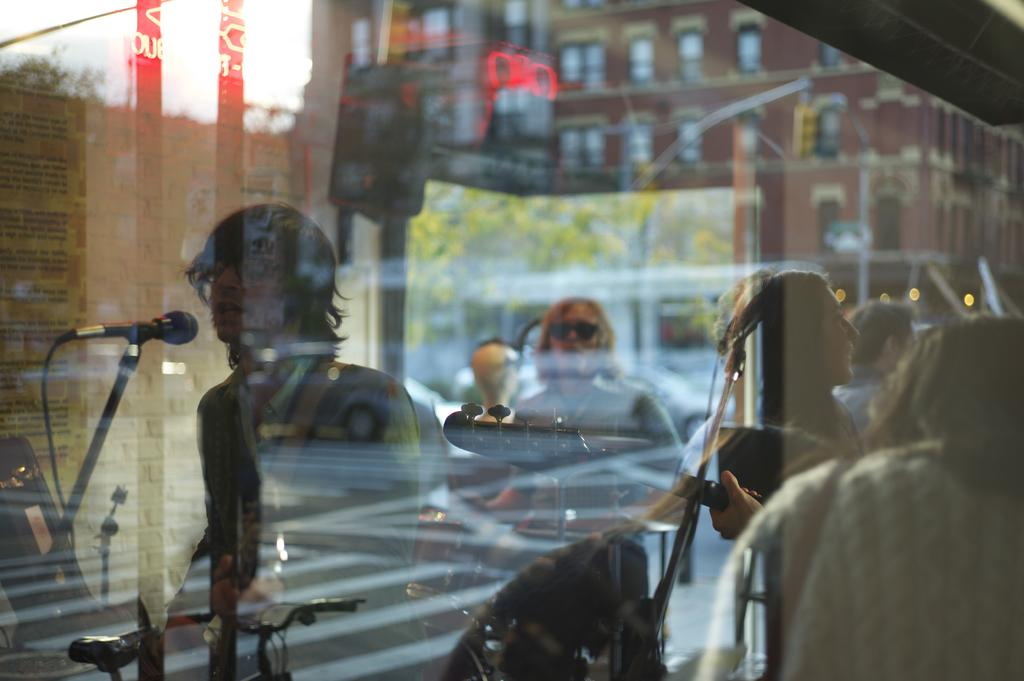What object is visible in the image that people are playing musical instruments through? There is a glass in the image that people are playing musical instruments through. What equipment is present in the image to amplify the sound of the musical instruments? There are microphones with mic stands in the image to amplify the sound of the musical instruments. What type of structure can be seen in the image? There is a building with windows in the image. What type of vegetation is present in the image? Trees are present in the image. What knowledge is being produced by the trees in the image? There is no knowledge being produced by the trees in the image; they are simply vegetation. What invention is being used to play musical instruments through the glass in the image? There is no specific invention being used to play musical instruments through the glass in the image; it is simply a glass. 